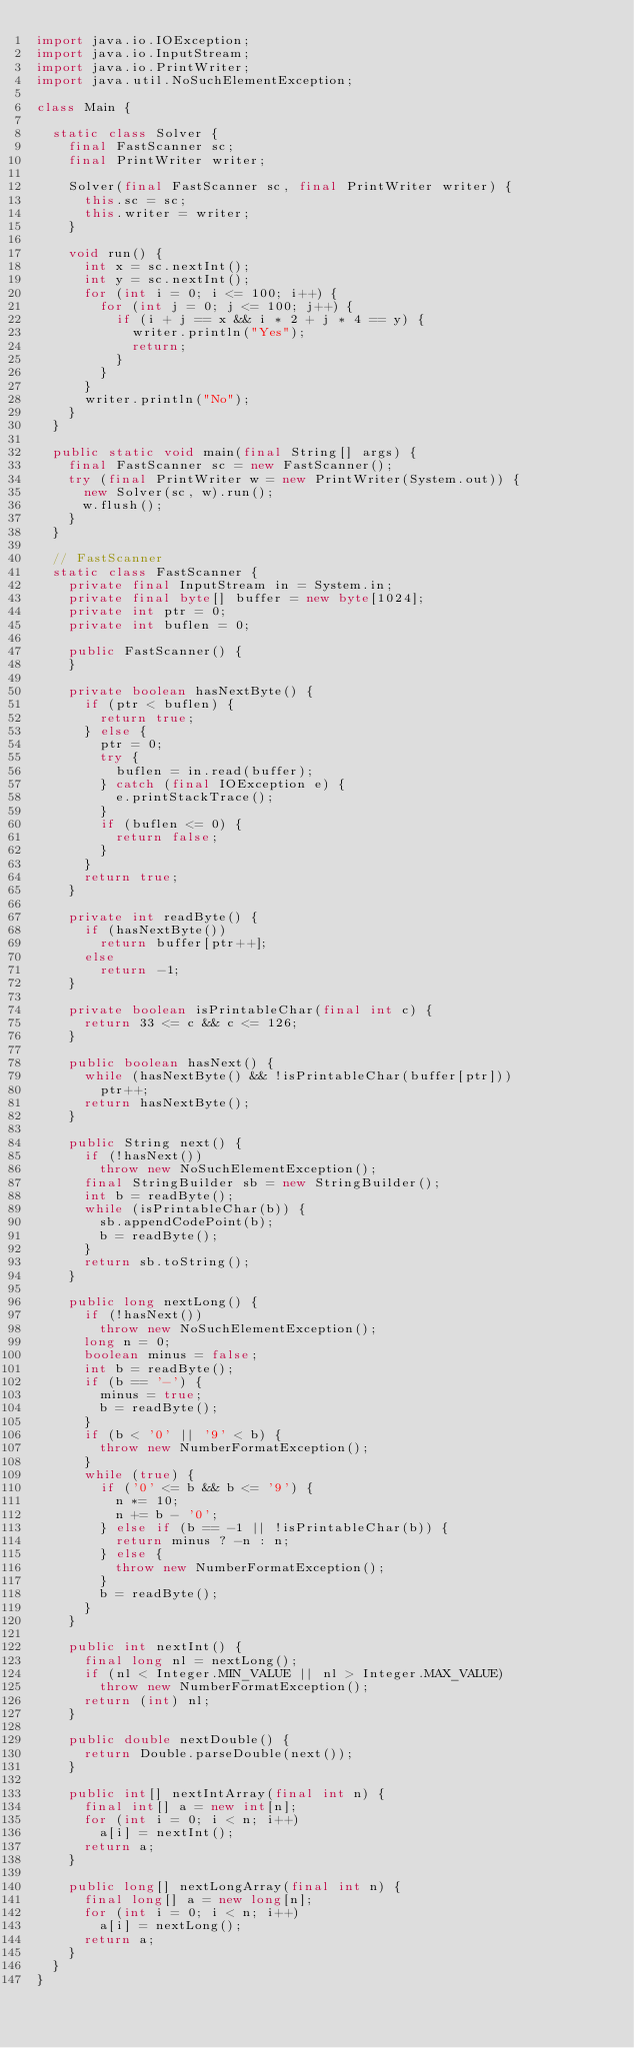<code> <loc_0><loc_0><loc_500><loc_500><_Java_>import java.io.IOException;
import java.io.InputStream;
import java.io.PrintWriter;
import java.util.NoSuchElementException;

class Main {

  static class Solver {
    final FastScanner sc;
    final PrintWriter writer;

    Solver(final FastScanner sc, final PrintWriter writer) {
      this.sc = sc;
      this.writer = writer;
    }

    void run() {
      int x = sc.nextInt();
      int y = sc.nextInt();
      for (int i = 0; i <= 100; i++) {
        for (int j = 0; j <= 100; j++) {
          if (i + j == x && i * 2 + j * 4 == y) {
            writer.println("Yes");
            return;
          }
        }
      }
      writer.println("No");
    }
  }

  public static void main(final String[] args) {
    final FastScanner sc = new FastScanner();
    try (final PrintWriter w = new PrintWriter(System.out)) {
      new Solver(sc, w).run();
      w.flush();
    }
  }

  // FastScanner
  static class FastScanner {
    private final InputStream in = System.in;
    private final byte[] buffer = new byte[1024];
    private int ptr = 0;
    private int buflen = 0;

    public FastScanner() {
    }

    private boolean hasNextByte() {
      if (ptr < buflen) {
        return true;
      } else {
        ptr = 0;
        try {
          buflen = in.read(buffer);
        } catch (final IOException e) {
          e.printStackTrace();
        }
        if (buflen <= 0) {
          return false;
        }
      }
      return true;
    }

    private int readByte() {
      if (hasNextByte())
        return buffer[ptr++];
      else
        return -1;
    }

    private boolean isPrintableChar(final int c) {
      return 33 <= c && c <= 126;
    }

    public boolean hasNext() {
      while (hasNextByte() && !isPrintableChar(buffer[ptr]))
        ptr++;
      return hasNextByte();
    }

    public String next() {
      if (!hasNext())
        throw new NoSuchElementException();
      final StringBuilder sb = new StringBuilder();
      int b = readByte();
      while (isPrintableChar(b)) {
        sb.appendCodePoint(b);
        b = readByte();
      }
      return sb.toString();
    }

    public long nextLong() {
      if (!hasNext())
        throw new NoSuchElementException();
      long n = 0;
      boolean minus = false;
      int b = readByte();
      if (b == '-') {
        minus = true;
        b = readByte();
      }
      if (b < '0' || '9' < b) {
        throw new NumberFormatException();
      }
      while (true) {
        if ('0' <= b && b <= '9') {
          n *= 10;
          n += b - '0';
        } else if (b == -1 || !isPrintableChar(b)) {
          return minus ? -n : n;
        } else {
          throw new NumberFormatException();
        }
        b = readByte();
      }
    }

    public int nextInt() {
      final long nl = nextLong();
      if (nl < Integer.MIN_VALUE || nl > Integer.MAX_VALUE)
        throw new NumberFormatException();
      return (int) nl;
    }

    public double nextDouble() {
      return Double.parseDouble(next());
    }

    public int[] nextIntArray(final int n) {
      final int[] a = new int[n];
      for (int i = 0; i < n; i++)
        a[i] = nextInt();
      return a;
    }

    public long[] nextLongArray(final int n) {
      final long[] a = new long[n];
      for (int i = 0; i < n; i++)
        a[i] = nextLong();
      return a;
    }
  }
}
</code> 